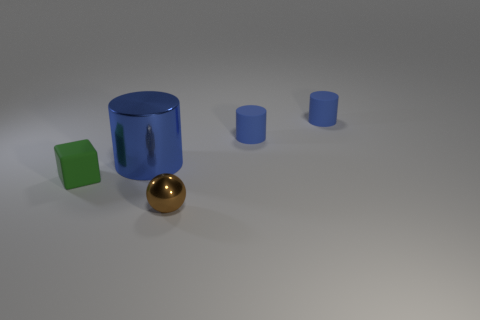Is there anything else that is the same shape as the brown metal object?
Give a very brief answer. No. Is the shape of the shiny thing that is behind the small green cube the same as the rubber object left of the big cylinder?
Provide a short and direct response. No. There is a object that is both in front of the big cylinder and left of the brown shiny object; what color is it?
Provide a succinct answer. Green. There is a shiny thing that is behind the metallic thing that is in front of the rubber block; are there any small blue things behind it?
Make the answer very short. Yes. How many things are big cyan shiny blocks or small rubber things?
Offer a very short reply. 3. Do the tiny brown object and the blue thing that is to the left of the small brown ball have the same material?
Offer a very short reply. Yes. Is there any other thing that is the same color as the big shiny cylinder?
Offer a very short reply. Yes. What number of things are metal things in front of the green matte object or shiny objects left of the small brown ball?
Ensure brevity in your answer.  2. What shape is the object that is both to the left of the metallic ball and in front of the large blue thing?
Keep it short and to the point. Cube. There is a small rubber thing that is on the left side of the brown shiny sphere; what number of small green rubber cubes are right of it?
Your answer should be compact. 0. 